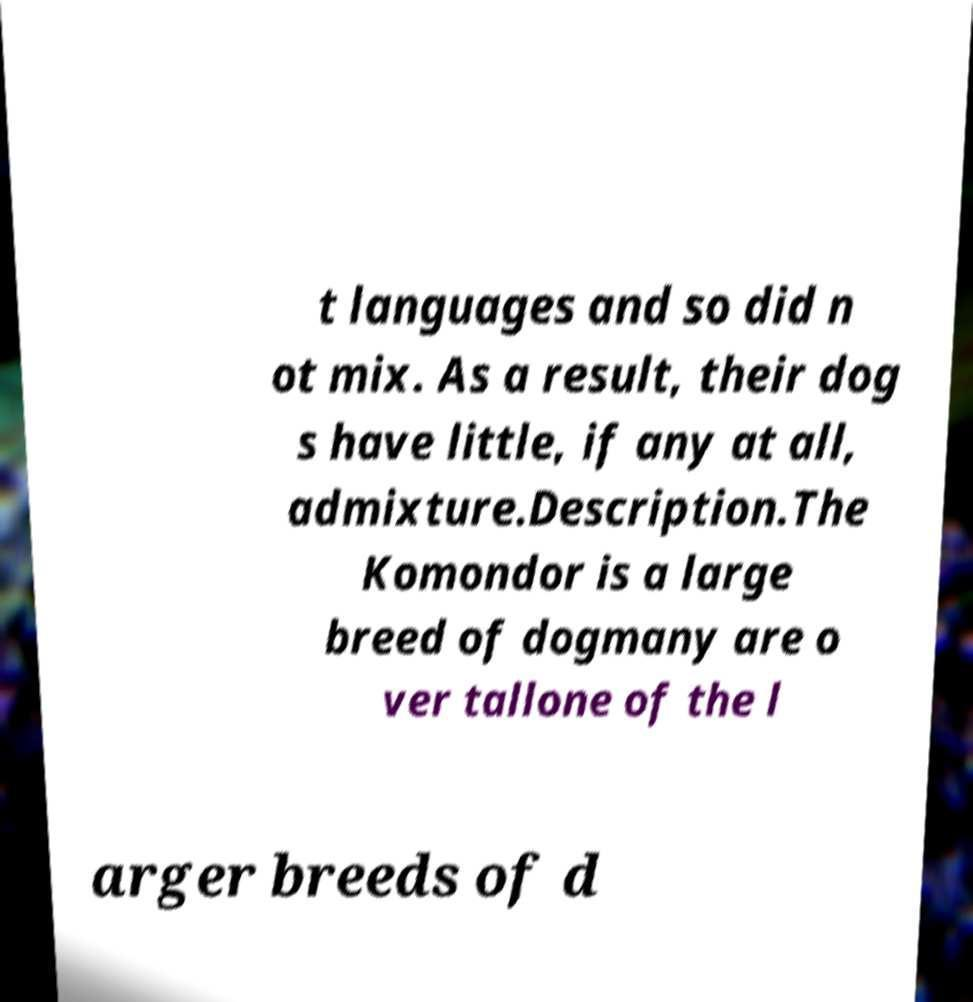Please read and relay the text visible in this image. What does it say? t languages and so did n ot mix. As a result, their dog s have little, if any at all, admixture.Description.The Komondor is a large breed of dogmany are o ver tallone of the l arger breeds of d 